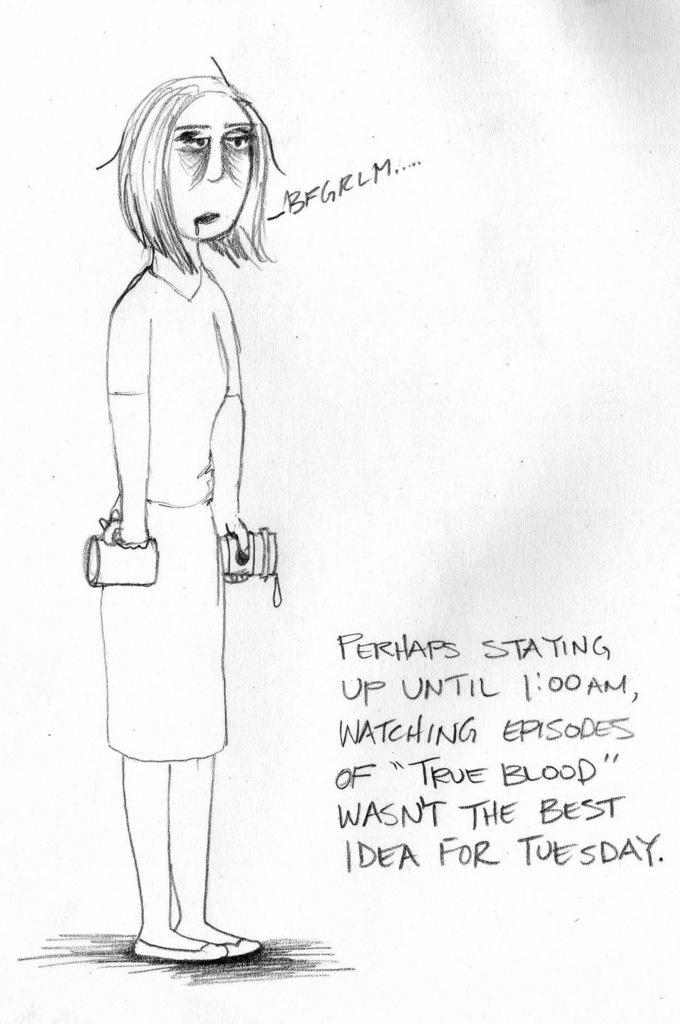Describe this image in one or two sentences. In this image I can see depiction of a woman. I can also see something is written over here and I can see white colour in the background. 